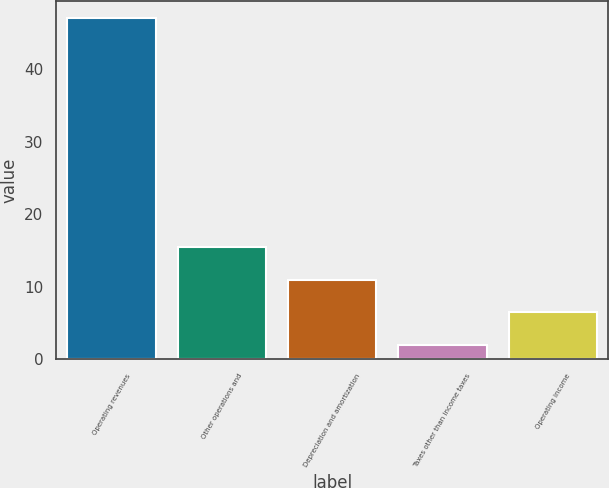<chart> <loc_0><loc_0><loc_500><loc_500><bar_chart><fcel>Operating revenues<fcel>Other operations and<fcel>Depreciation and amortization<fcel>Taxes other than income taxes<fcel>Operating income<nl><fcel>47<fcel>15.5<fcel>11<fcel>2<fcel>6.5<nl></chart> 